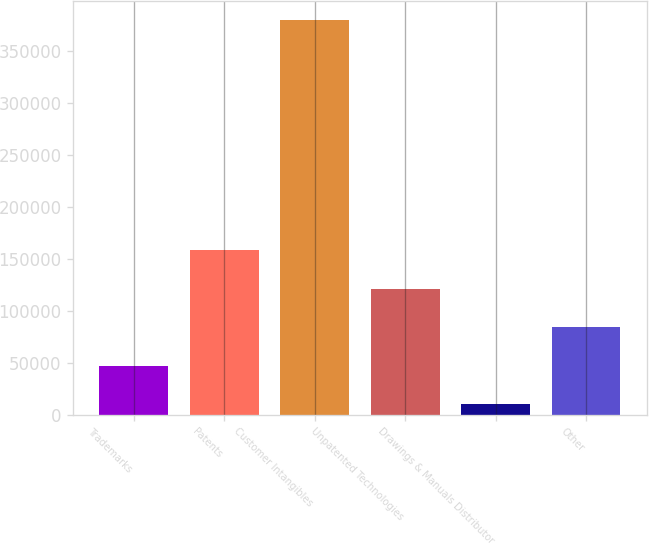Convert chart. <chart><loc_0><loc_0><loc_500><loc_500><bar_chart><fcel>Trademarks<fcel>Patents<fcel>Customer Intangibles<fcel>Unpatented Technologies<fcel>Drawings & Manuals Distributor<fcel>Other<nl><fcel>47328.2<fcel>157927<fcel>379124<fcel>121061<fcel>10462<fcel>84194.4<nl></chart> 